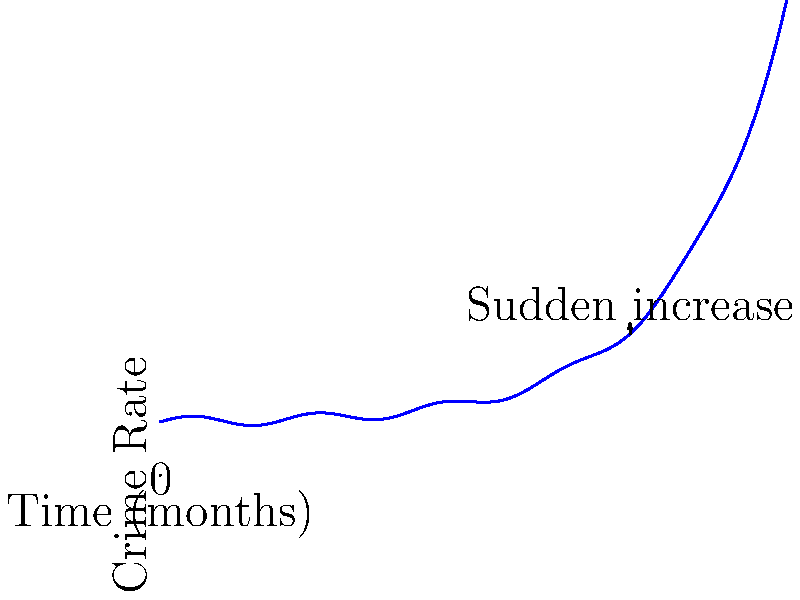As a police officer analyzing crime rate data, you notice an unusual pattern in the graph above. What type of suspicious trend does this graph depict, and at approximately what point in time does it become most evident? To analyze this graph as a police officer, we should follow these steps:

1. Observe the overall pattern: The graph shows a cyclical pattern with gradual ups and downs, likely representing normal seasonal variations in crime rates.

2. Identify the anomaly: Around the 30-month mark, there's a noticeable change in the pattern.

3. Analyze the change: After the 30-month point, the crime rate begins to increase more rapidly than the previous cyclical pattern would suggest.

4. Characterize the trend: This sudden and sustained increase in crime rate is indicative of an exponential growth pattern.

5. Pinpoint the most evident point: The exponential trend becomes most apparent around the 45-month mark, where there's a steep upward curve that clearly deviates from the earlier pattern.

6. Interpret the significance: As a police officer, this type of trend could signify the emergence of a new criminal operation, the introduction of a new drug in the area, or a significant change in socio-economic factors affecting crime rates.

This exponential growth in crime rates, becoming most evident at the 45-month mark, is the suspicious pattern that would be of most concern to law enforcement.
Answer: Exponential growth in crime rate, most evident at 45 months 